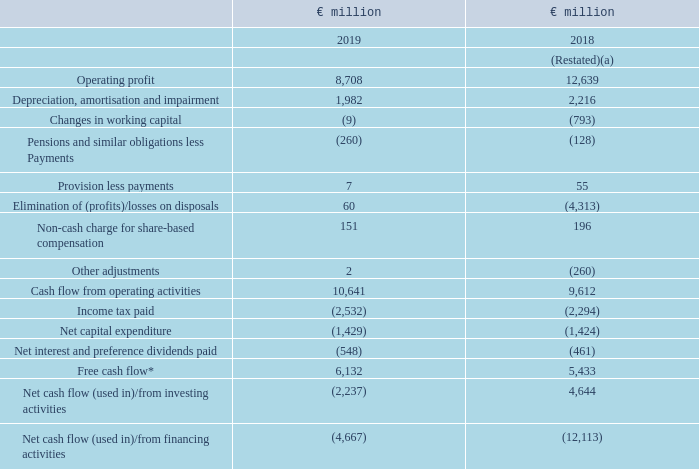Cash Flow
Cash flow from operating activities was up by €1.0 billion mainly driven by working capital improvement in 2019 compared to the prior year which was impacted by the disposal of spreads. Gross margin improvement had a favourable contribution a result of strong delivery from 5-S savings programmes. Overheads and brand and marketing efficiencies also had a favourable contribution as a result of our zero-based-budgeting programme.
(a) Restated following adoption of IFRS 16. See note 1 and note 24 for further details.
* Certain measures used in our reporting are not defined under IFRS. For further
information about these measures, please refer to the commentary on non-GAAP
measures on pages 27 to 32.
Net cash outflow as a result of investing activities was €2.2 billion compared to an inflow of €4.6 billion in the prior year which included €7.1 billion from the disposal of spreads business.
Net outflow from financing activities was €4.7 billion compared to €12.1
billion in the prior year. 2018 included €6.0 billion relating to repurchase of
shares. In 2019 borrowings net of repayments was €1.4 billion higher than
the prior year.
What caused the increase in the cash flow from operating activities in 2019? Mainly driven by working capital improvement in 2019 compared to the prior year which was impacted by the disposal of spreads. What contributed to the Gross Profit margin improvement? A result of strong delivery from 5-s savings programmes. What constituted the cash inflow from investing activities in 2018? Included €7.1 billion from the disposal of spreads business. What is the change in the operating profit? 
Answer scale should be: thousand. 8,708 - 12,639
Answer: -3931. What is the increase / (decrease) in the Free Cash Flow?
Answer scale should be: thousand. 6,132 - 5,433
Answer: 699. What is the average Depreciation, amortisation and impairment?
Answer scale should be: thousand. (1,982 + 2,216) / 2
Answer: 2099. 